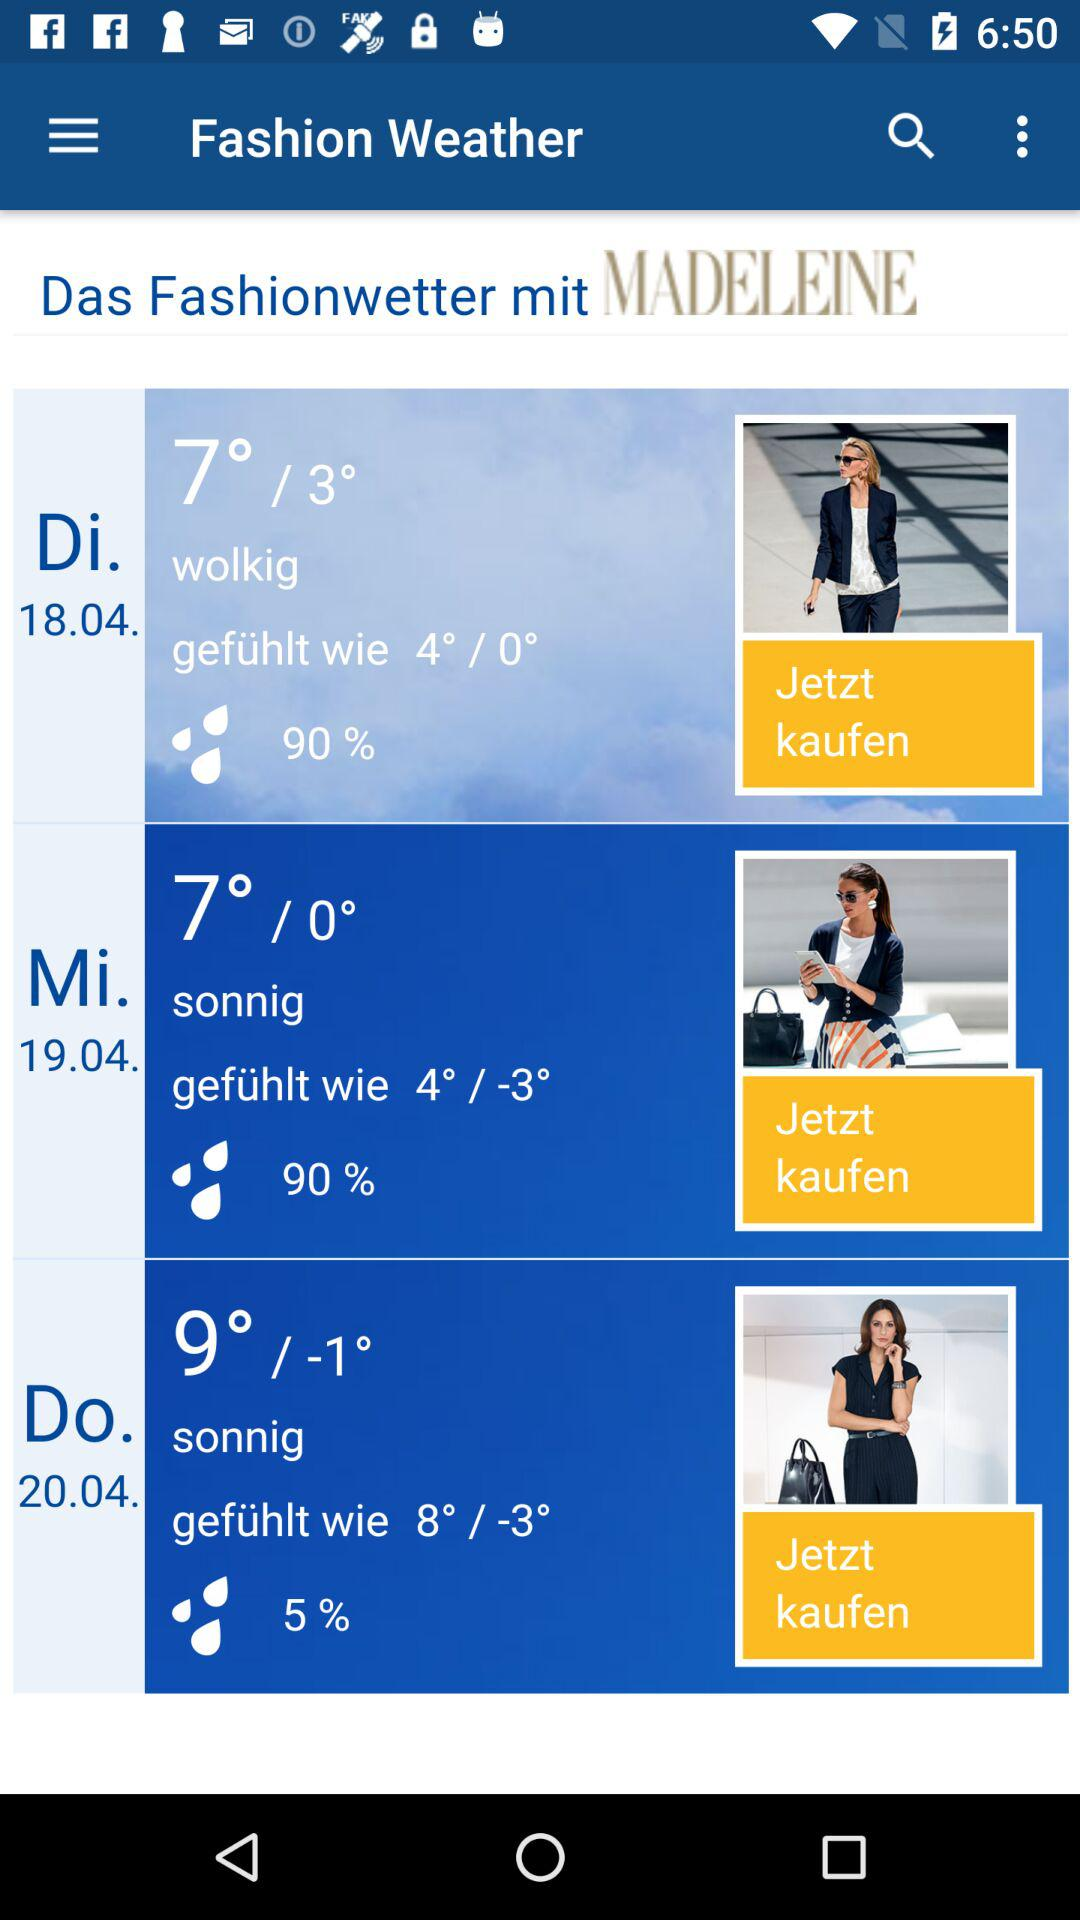How many days are there in the forecast?
Answer the question using a single word or phrase. 3 